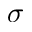<formula> <loc_0><loc_0><loc_500><loc_500>\sigma</formula> 